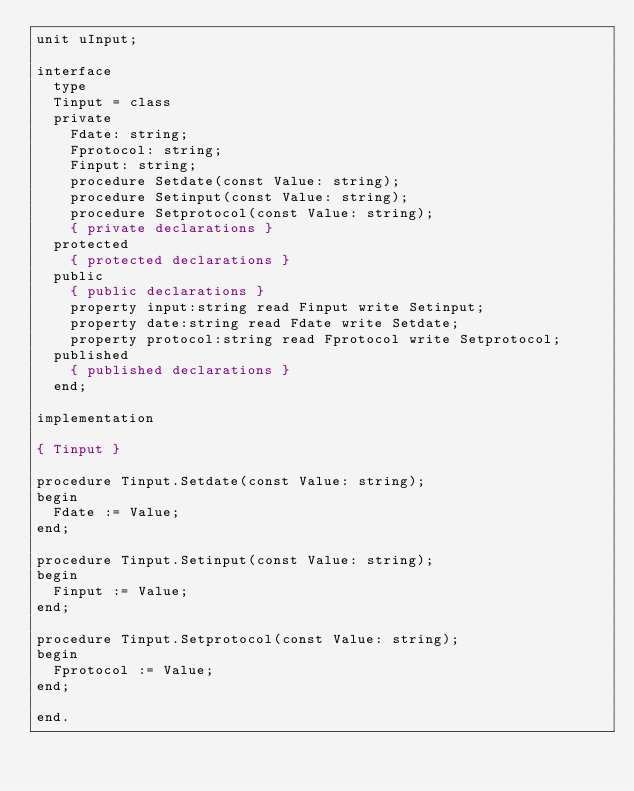Convert code to text. <code><loc_0><loc_0><loc_500><loc_500><_Pascal_>unit uInput;

interface
  type
  Tinput = class
  private
    Fdate: string;
    Fprotocol: string;
    Finput: string;
    procedure Setdate(const Value: string);
    procedure Setinput(const Value: string);
    procedure Setprotocol(const Value: string);
    { private declarations }
  protected
    { protected declarations }
  public
    { public declarations }
    property input:string read Finput write Setinput;
    property date:string read Fdate write Setdate;
    property protocol:string read Fprotocol write Setprotocol;
  published
    { published declarations }
  end;

implementation

{ Tinput }

procedure Tinput.Setdate(const Value: string);
begin
  Fdate := Value;
end;

procedure Tinput.Setinput(const Value: string);
begin
  Finput := Value;
end;

procedure Tinput.Setprotocol(const Value: string);
begin
  Fprotocol := Value;
end;

end.
</code> 